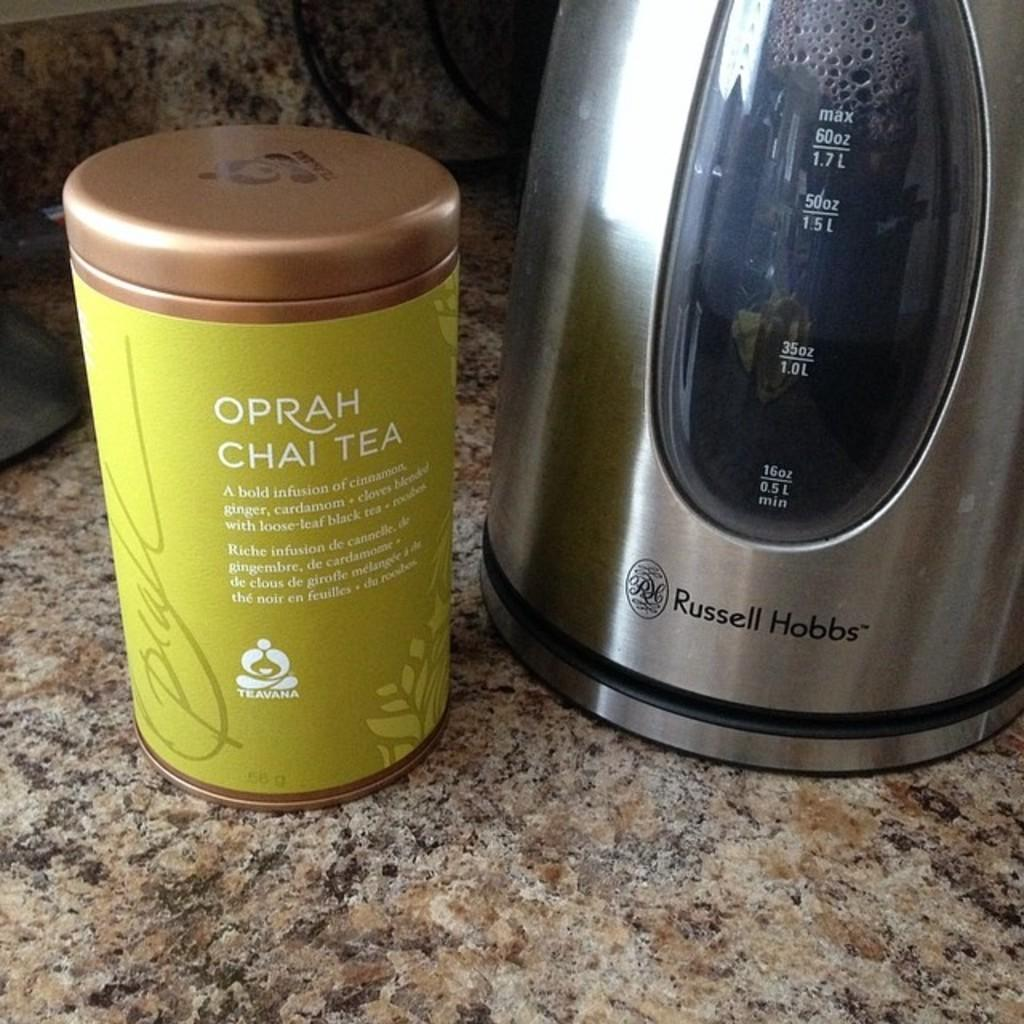<image>
Relay a brief, clear account of the picture shown. A canister of Oprah Chai Tea sits next to a Russell Hobbs tea kettle. 